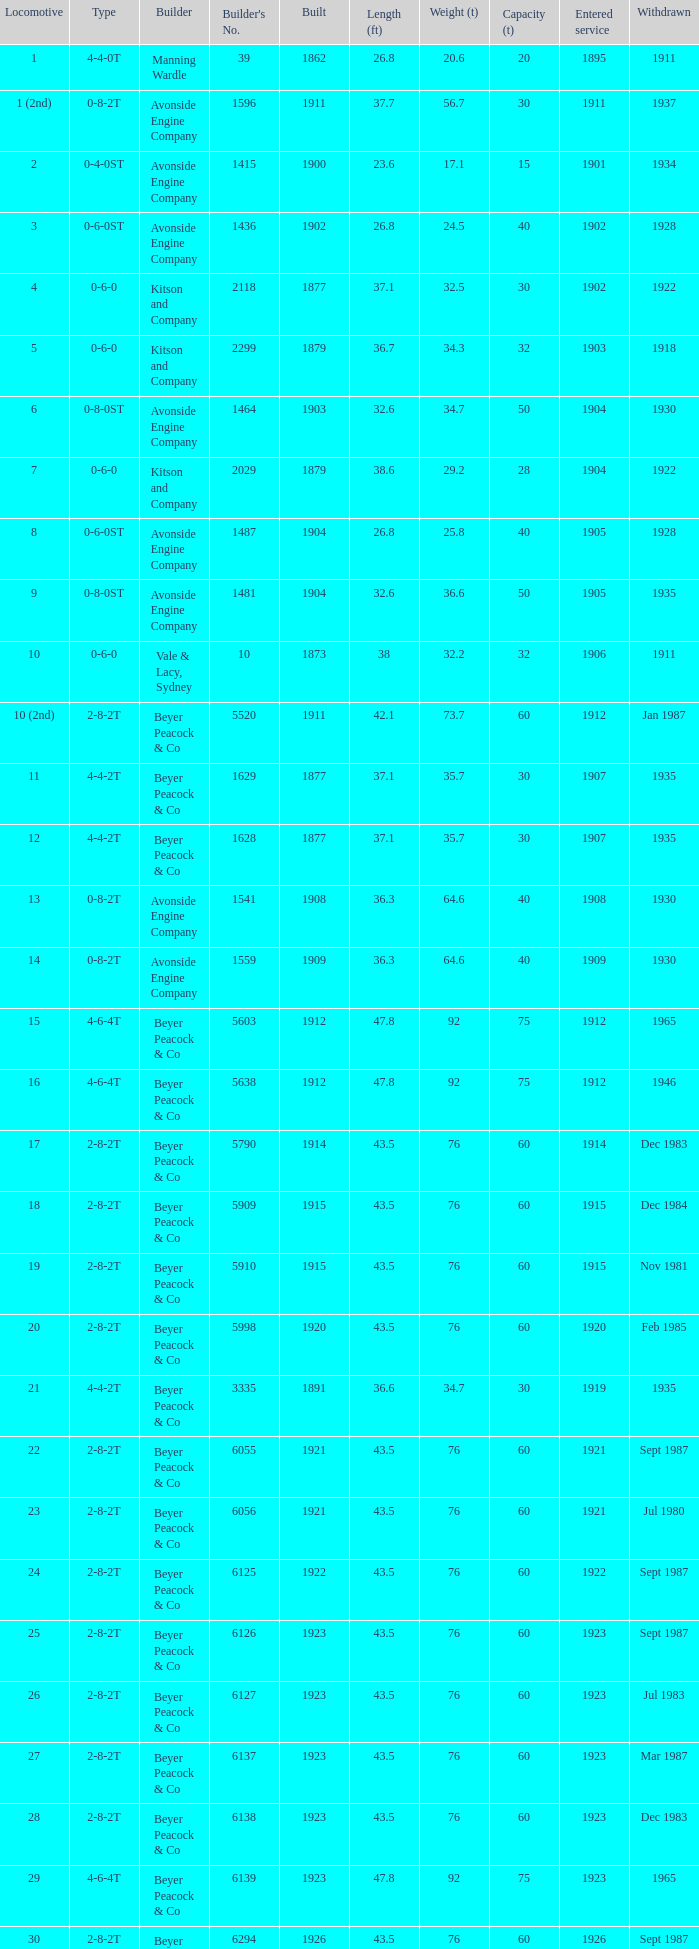Which locomotive had a 2-8-2t type, entered service year prior to 1915, and which was built after 1911? 17.0. 